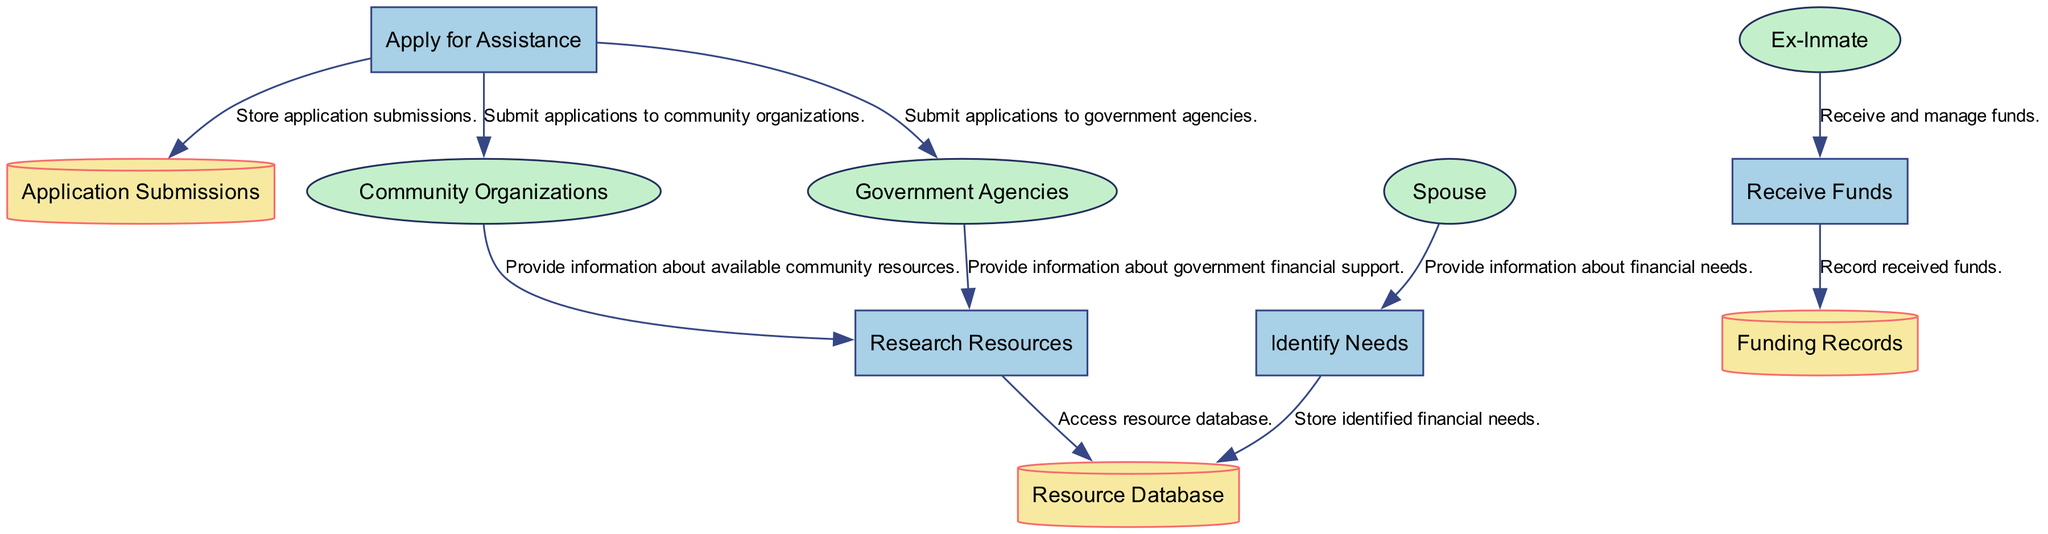What is the first process in the diagram? The diagram lists the processes, starting with "Identify Needs" as the first one defined in the data.
Answer: Identify Needs How many external entities are present in the diagram? The diagram includes four external entities: Spouse, Ex-Inmate, Community Organizations, and Government Agencies.
Answer: 4 What does the "Receive Funds" process store? The "Receive Funds" process is connected to the "Funding Records" data store, where records of received funds are documented.
Answer: Funding Records Which external entity provides information about available community resources? The external entity "Community Organizations" offers information regarding the community resources available for financial support, as indicated in the data flow.
Answer: Community Organizations What is the last process in the diagram? The last process is "Receive Funds," which represents the final step in the flow of financial support, following the applications submitted.
Answer: Receive Funds Which data store is associated with application submissions? The data store named "Application Submissions" is specifically designated for storing records of applications that have been submitted for financial assistance.
Answer: Application Submissions Which two external entities are involved in submitting applications? The "Community Organizations" and "Government Agencies" are the two external entities specified for submitting applications in the process flow.
Answer: Community Organizations, Government Agencies What information does the Spouse provide in the diagram? The Spouse provides information about the financial needs of the ex-inmate, which is critical for assessing their support requirements.
Answer: Financial needs Which process accesses the resource database? The "Research Resources" process is responsible for accessing the "Resource Database" to gather information about financial resources available for support.
Answer: Research Resources 